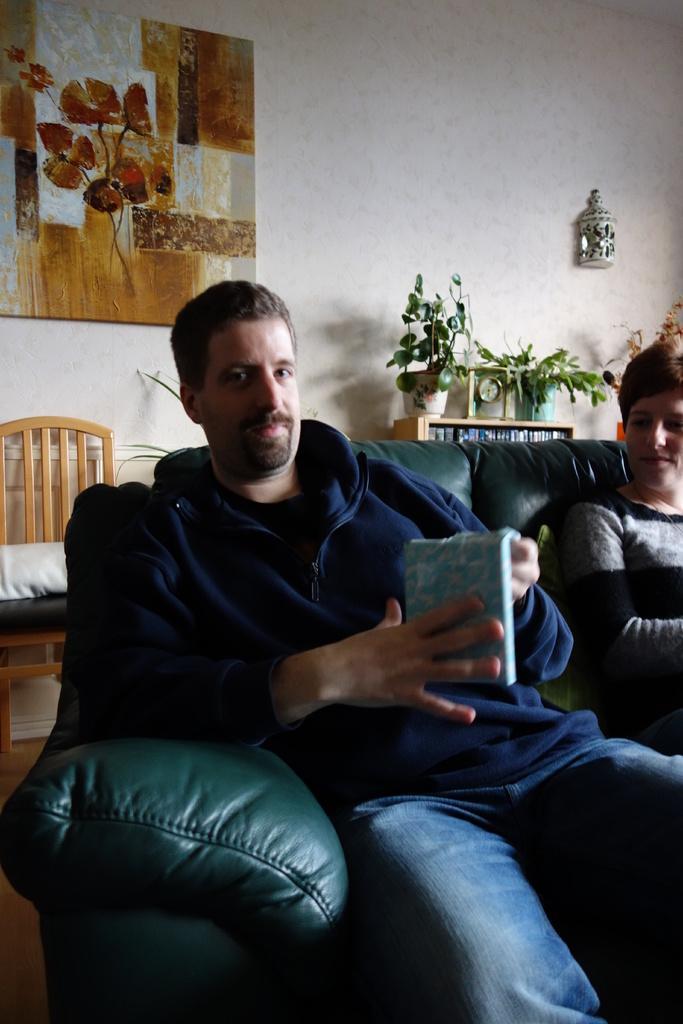Describe this image in one or two sentences. This is a picture of a man sitting a in couch , another man sitting in the couch and in back ground there is frame attached to the wall , chair , plant and books. 